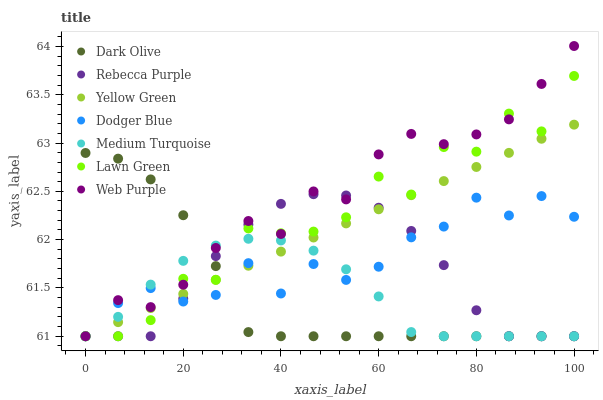Does Dark Olive have the minimum area under the curve?
Answer yes or no. Yes. Does Web Purple have the maximum area under the curve?
Answer yes or no. Yes. Does Yellow Green have the minimum area under the curve?
Answer yes or no. No. Does Yellow Green have the maximum area under the curve?
Answer yes or no. No. Is Yellow Green the smoothest?
Answer yes or no. Yes. Is Lawn Green the roughest?
Answer yes or no. Yes. Is Dark Olive the smoothest?
Answer yes or no. No. Is Dark Olive the roughest?
Answer yes or no. No. Does Lawn Green have the lowest value?
Answer yes or no. Yes. Does Web Purple have the highest value?
Answer yes or no. Yes. Does Yellow Green have the highest value?
Answer yes or no. No. Does Yellow Green intersect Medium Turquoise?
Answer yes or no. Yes. Is Yellow Green less than Medium Turquoise?
Answer yes or no. No. Is Yellow Green greater than Medium Turquoise?
Answer yes or no. No. 